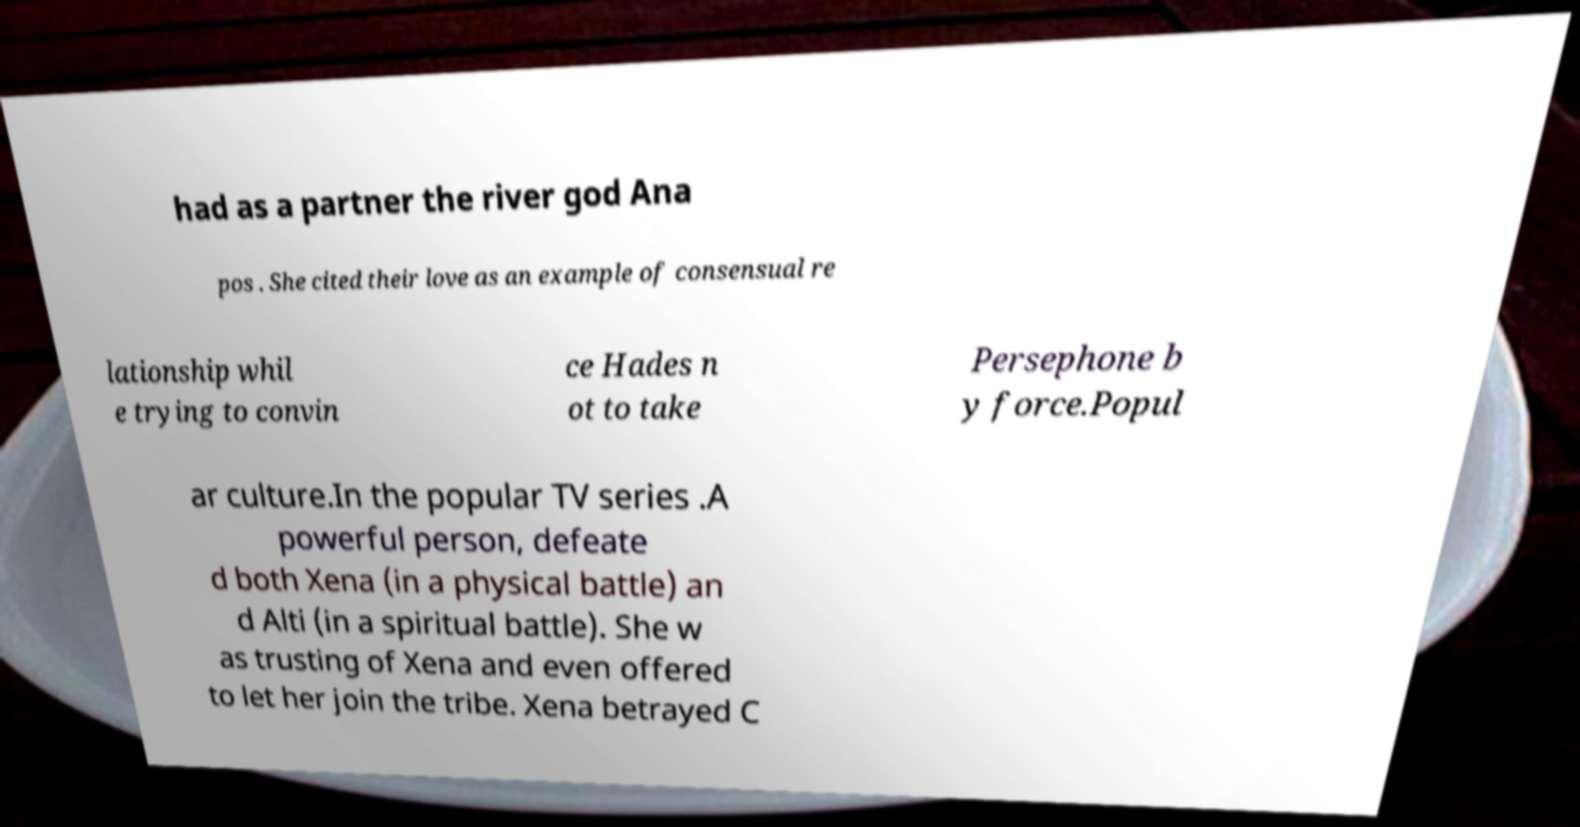What messages or text are displayed in this image? I need them in a readable, typed format. had as a partner the river god Ana pos . She cited their love as an example of consensual re lationship whil e trying to convin ce Hades n ot to take Persephone b y force.Popul ar culture.In the popular TV series .A powerful person, defeate d both Xena (in a physical battle) an d Alti (in a spiritual battle). She w as trusting of Xena and even offered to let her join the tribe. Xena betrayed C 